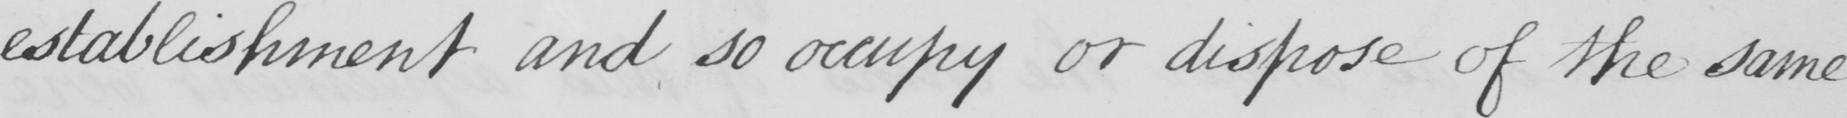Please transcribe the handwritten text in this image. establishmnent and so occupy or dispose of the same 